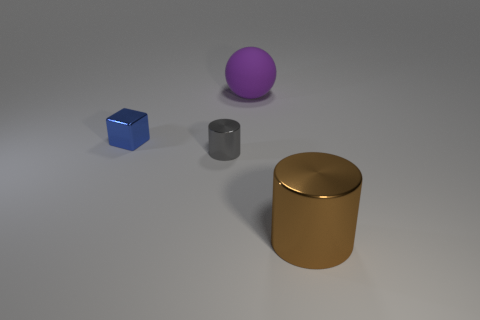Add 2 balls. How many objects exist? 6 Subtract all balls. How many objects are left? 3 Add 4 large metal things. How many large metal things are left? 5 Add 4 red balls. How many red balls exist? 4 Subtract 0 cyan cubes. How many objects are left? 4 Subtract all big green objects. Subtract all cylinders. How many objects are left? 2 